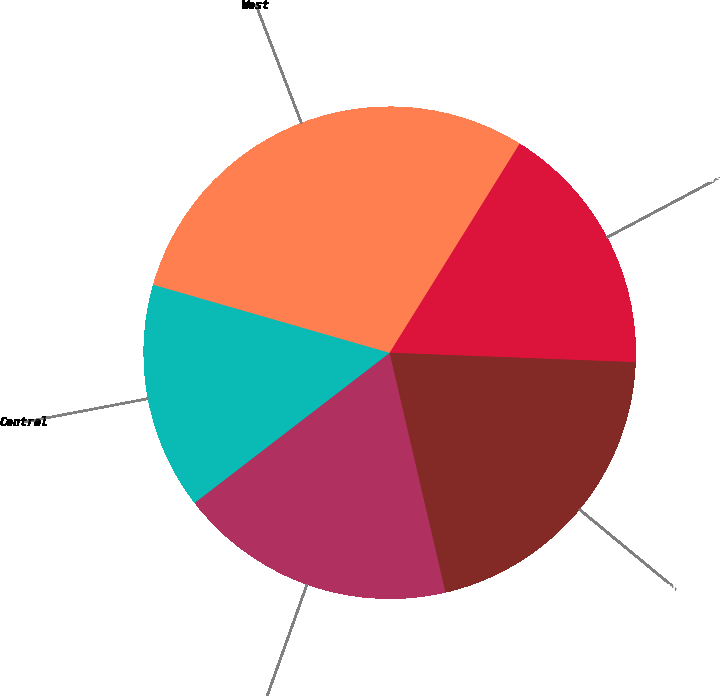Convert chart. <chart><loc_0><loc_0><loc_500><loc_500><pie_chart><fcel>East<fcel>Central<fcel>West<fcel>Houston<fcel>Other<nl><fcel>18.21%<fcel>14.9%<fcel>29.39%<fcel>16.76%<fcel>20.74%<nl></chart> 